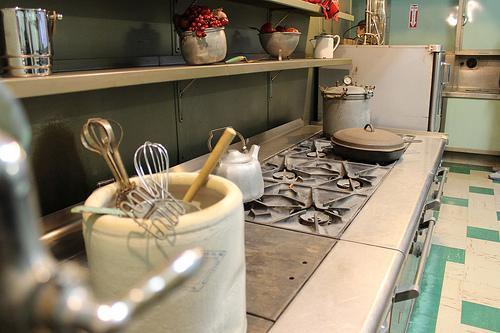How many pans?
Give a very brief answer. 1. 